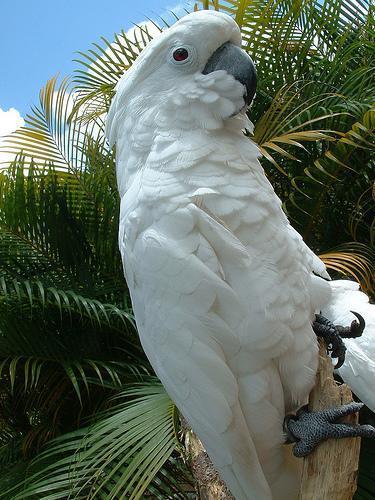How many birds are in the photo?
Give a very brief answer. 1. 